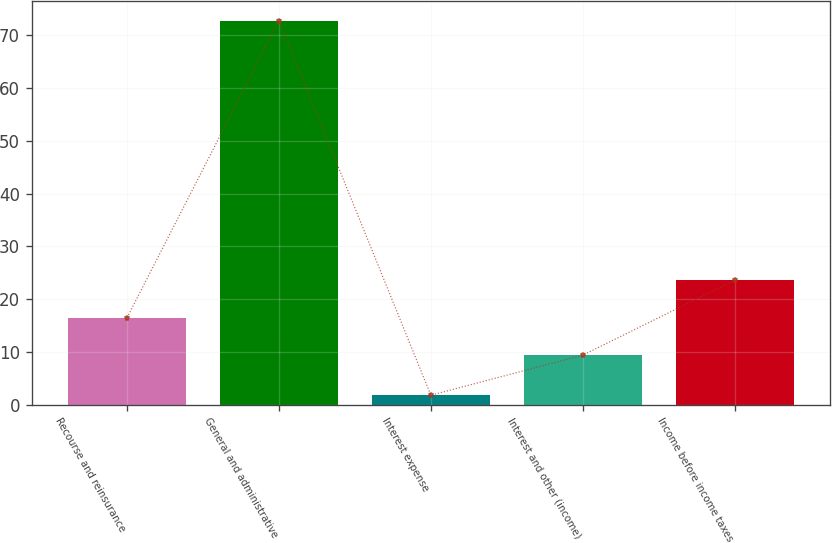Convert chart. <chart><loc_0><loc_0><loc_500><loc_500><bar_chart><fcel>Recourse and reinsurance<fcel>General and administrative<fcel>Interest expense<fcel>Interest and other (income)<fcel>Income before income taxes<nl><fcel>16.5<fcel>72.8<fcel>1.8<fcel>9.4<fcel>23.6<nl></chart> 